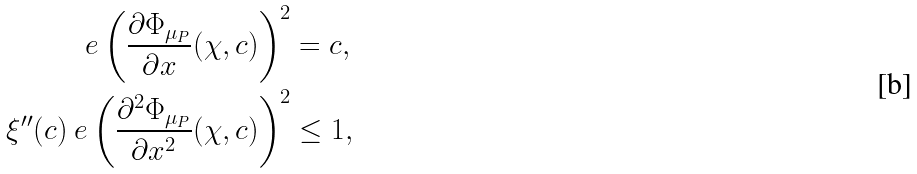Convert formula to latex. <formula><loc_0><loc_0><loc_500><loc_500>\ e \left ( \frac { \partial \Phi _ { \mu _ { P } } } { \partial x } ( \chi , c ) \right ) ^ { 2 } & = c , \\ \xi ^ { \prime \prime } ( c ) \ e \left ( \frac { \partial ^ { 2 } \Phi _ { \mu _ { P } } } { \partial x ^ { 2 } } ( \chi , c ) \right ) ^ { 2 } & \leq 1 ,</formula> 